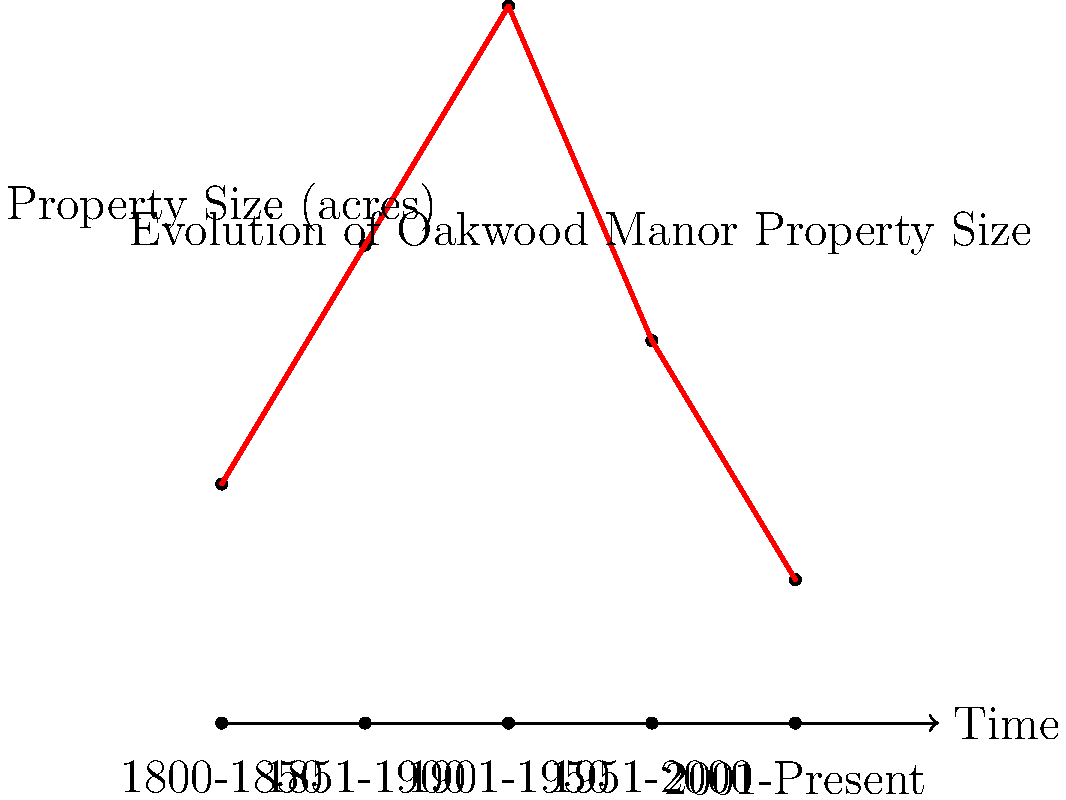Based on the timeline and property size graph of Oakwood Manor, during which time period did the property reach its maximum size, and what factors might have contributed to the subsequent decrease in property size? To answer this question, we need to analyze the graph step-by-step:

1. The graph shows the evolution of Oakwood Manor's property size from 1800 to the present day.

2. The property size is represented on the y-axis in acres, while the x-axis shows the time periods.

3. Examining the red line, we can see that:
   - From 1800-1850, the property was about 5 acres.
   - From 1851-1900, it increased to about 10 acres.
   - From 1901-1950, it reached its peak at about 15 acres.
   - From 1951-2000, it decreased to about 8 acres.
   - From 2001-Present, it further decreased to about 3 acres.

4. The maximum size was reached during the 1901-1950 period.

5. Factors that might have contributed to the subsequent decrease in property size could include:
   - Urban development and expansion pressures
   - Economic changes forcing the sale of portions of the property
   - Changes in family ownership or inheritance divisions
   - Zoning law changes
   - Tax burdens leading to property sales

6. As a historian, it's important to consider the broader historical context:
   - The peak in 1901-1950 might coincide with the property's golden age.
   - The post-1950 decrease might reflect broader trends in urbanization and the breaking up of large estates.
Answer: 1901-1950; urban development, economic changes, inheritance divisions, zoning changes, and tax burdens. 